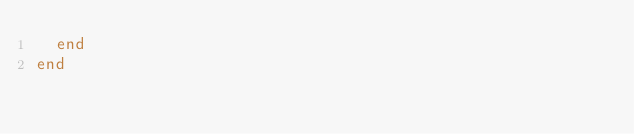<code> <loc_0><loc_0><loc_500><loc_500><_Ruby_>  end
end
</code> 